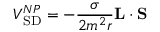Convert formula to latex. <formula><loc_0><loc_0><loc_500><loc_500>V _ { S D } ^ { N P } = - { \frac { \sigma } { 2 m ^ { 2 } r } } { L } \cdot { S }</formula> 